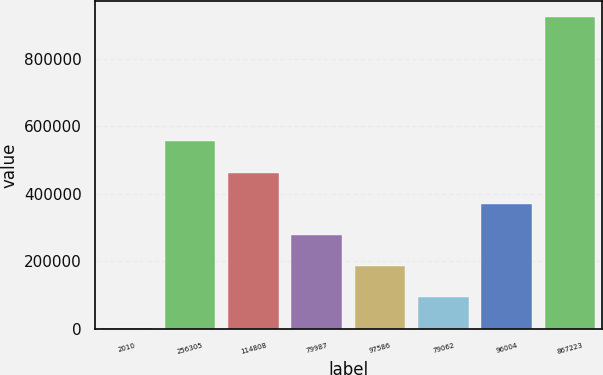Convert chart. <chart><loc_0><loc_0><loc_500><loc_500><bar_chart><fcel>2010<fcel>256305<fcel>114808<fcel>79987<fcel>97586<fcel>79062<fcel>96004<fcel>867223<nl><fcel>2009<fcel>555024<fcel>462855<fcel>278517<fcel>186347<fcel>94178.2<fcel>370686<fcel>923701<nl></chart> 